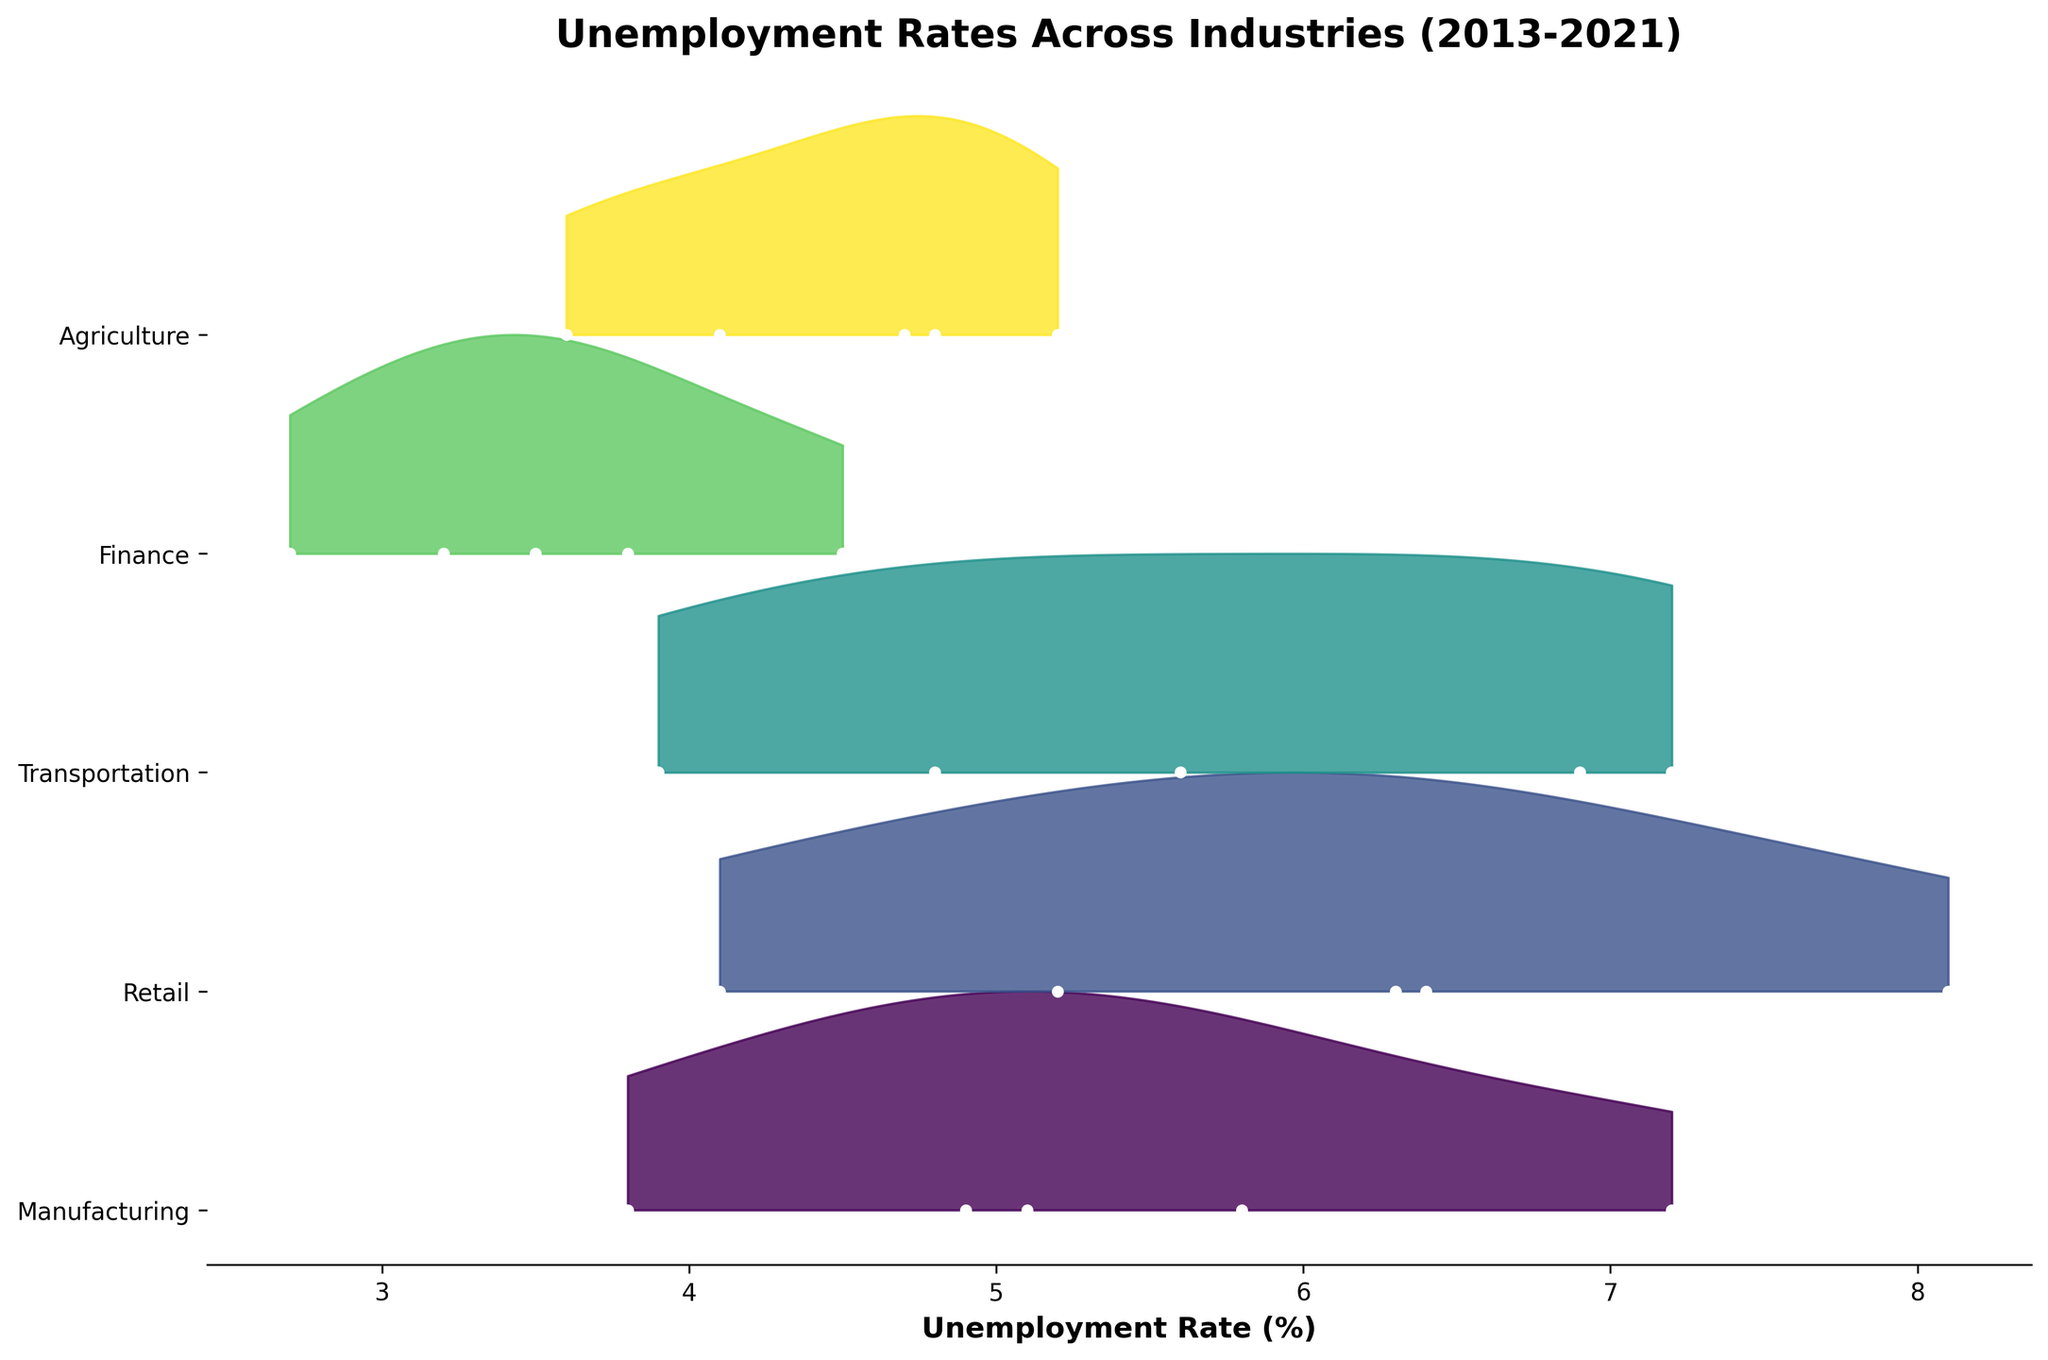what is the highest unemployment rate in the Retail industry? By observing the peaks on the ridgeline plot associated with the Retail industry, we see that the highest unemployment rate occurred in 2013, with an unemployment rate of 8.1%.
Answer: 8.1% Which industry experienced the lowest unemployment rate in the most recent year (2021)? In 2021, Finance has the lowest unemployment rate compared to other industries. By comparing the 2021 data points across all industries, Finance recorded the lowest at 3.5%.
Answer: Finance How did the unemployment rate in the Manufacturing industry change from 2019 to 2021? We can compare the data points for Manufacturing in 2019 and 2021. In 2019, the unemployment rate was 3.8%, and in 2021, it was 5.1%, indicating an increase of 1.3%.
Answer: Increased by 1.3% Which industry had the most significant increase in unemployment rate from 2019 to 2021? By comparing the data points for all industries from 2019 to 2021, Transportation had the most significant increase, from 3.9% to 7.2%, an increase of 3.3%.
Answer: Transportation What is the trend of unemployment rates in the Finance industry from 2013 to 2021? Observing the ridgeline plot for Finance from 2013 to 2021, the unemployment rate generally decreased from 4.5% in 2013 to 2.7% in 2019, then slightly increased to 3.5% in 2021.
Answer: Decrease overall, slight increase in 2021 Between Manufacturing and Agriculture, which industry had a more significant unemployment rate fluctuation over the years? Comparing the ridgeline plots for Manufacturing and Agriculture, Manufacturing shows a wider range of fluctuations from 7.2% in 2013 to 3.8% in 2019, while Agriculture had smaller changes.
Answer: Manufacturing In which year did the Transportation industry have the lowest unemployment rate? By observing the data points in the ridgeline plot for Transportation, the lowest unemployment rate occurred in 2019, at 3.9%.
Answer: 2019 Which industries showed an increase in unemployment rate from 2017 to 2021? By evaluating the data points in the ridgeline plot between 2017 and 2021 for each industry, Manufacturing, Retail, Transportation, and Agriculture show increases in that period.
Answer: Manufacturing, Retail, Transportation, Agriculture 